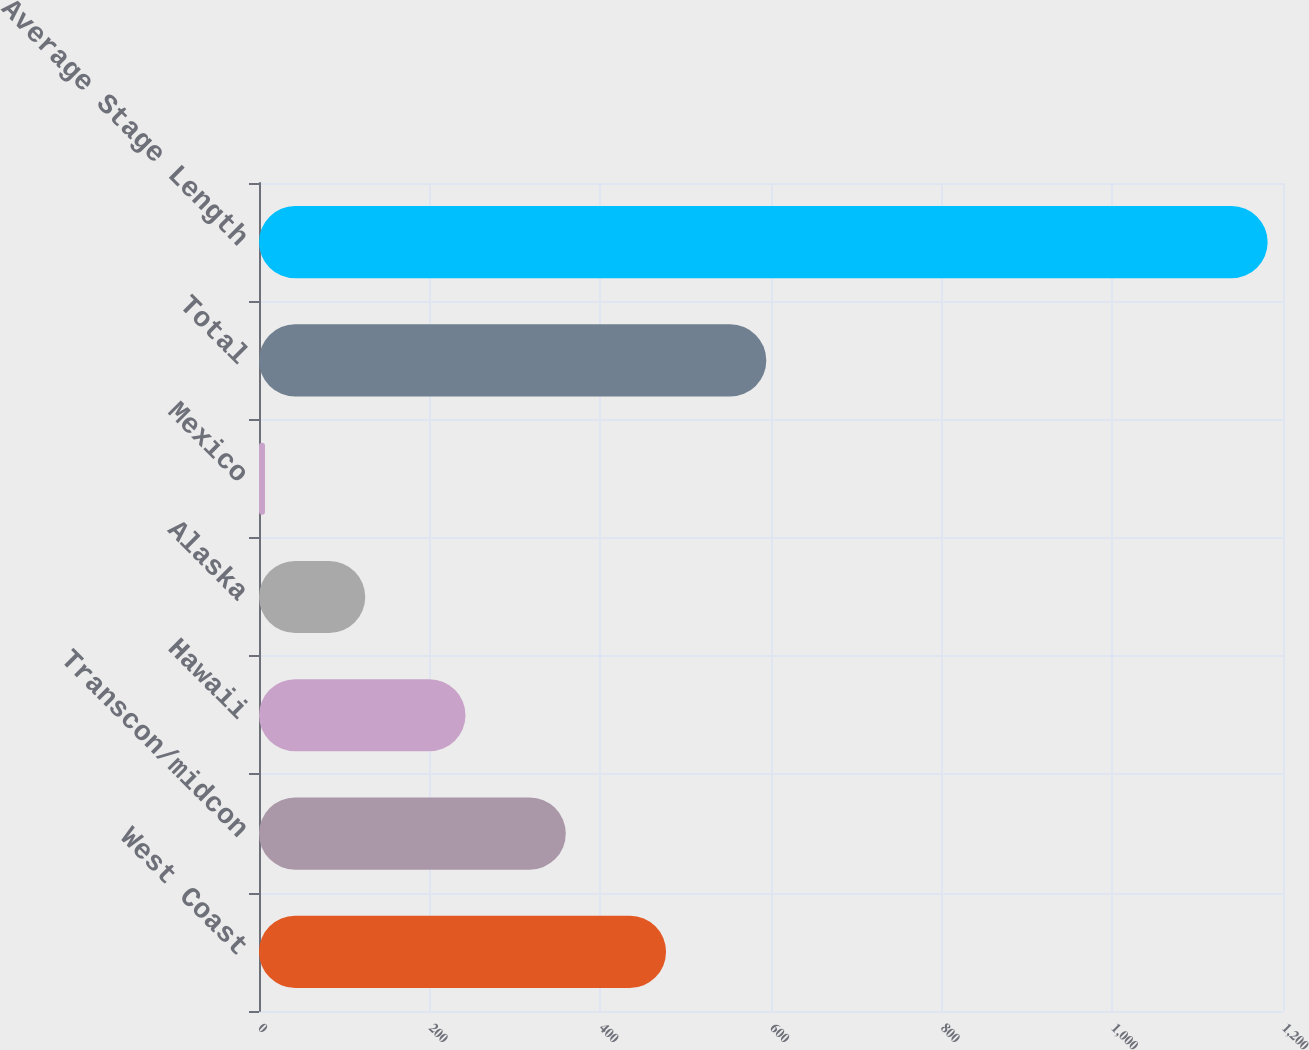Convert chart. <chart><loc_0><loc_0><loc_500><loc_500><bar_chart><fcel>West Coast<fcel>Transcon/midcon<fcel>Hawaii<fcel>Alaska<fcel>Mexico<fcel>Total<fcel>Average Stage Length<nl><fcel>477<fcel>359.5<fcel>242<fcel>124.5<fcel>7<fcel>594.5<fcel>1182<nl></chart> 